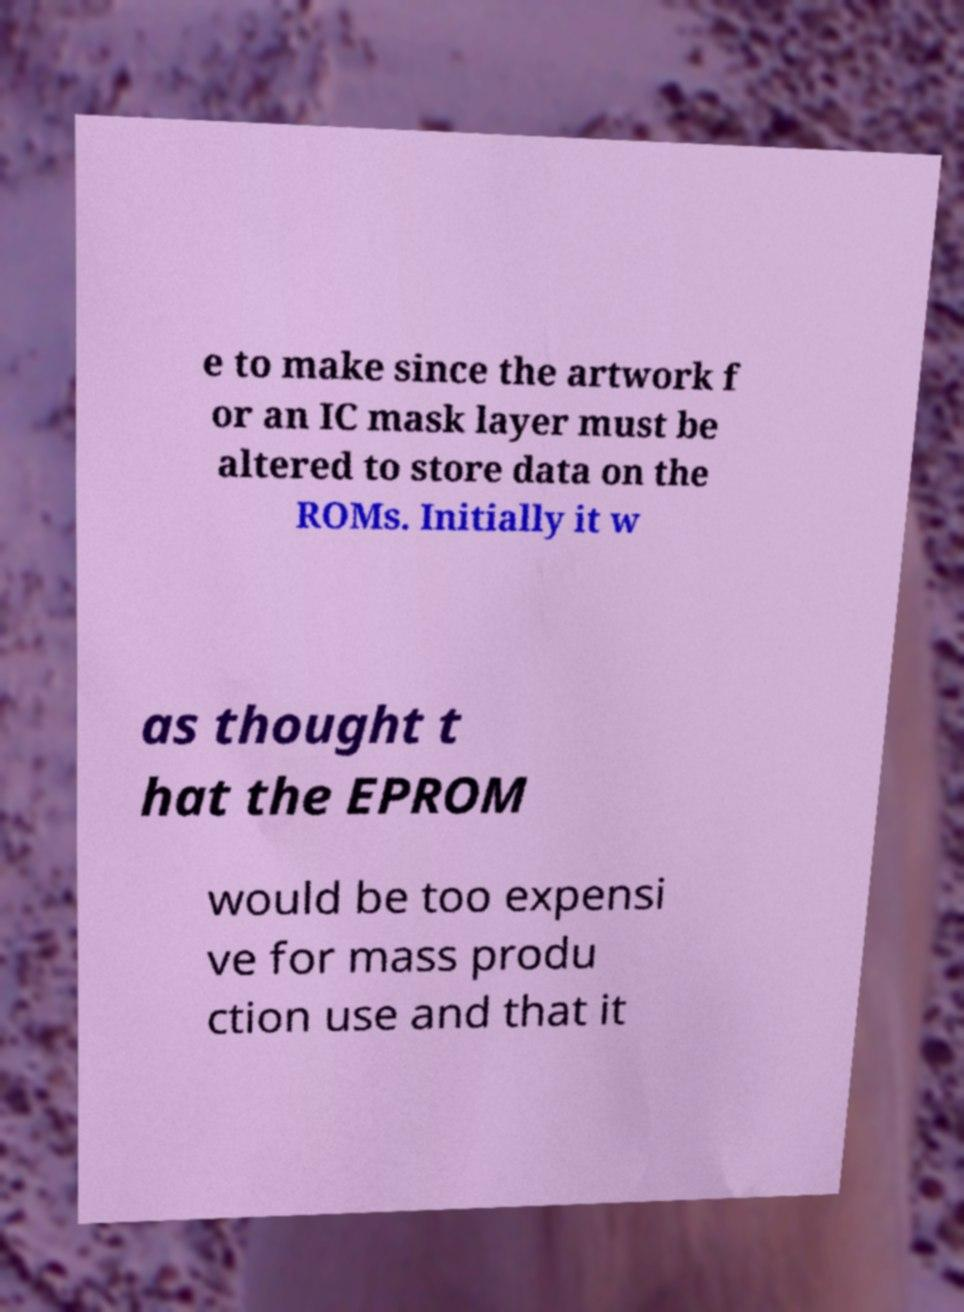Please read and relay the text visible in this image. What does it say? e to make since the artwork f or an IC mask layer must be altered to store data on the ROMs. Initially it w as thought t hat the EPROM would be too expensi ve for mass produ ction use and that it 